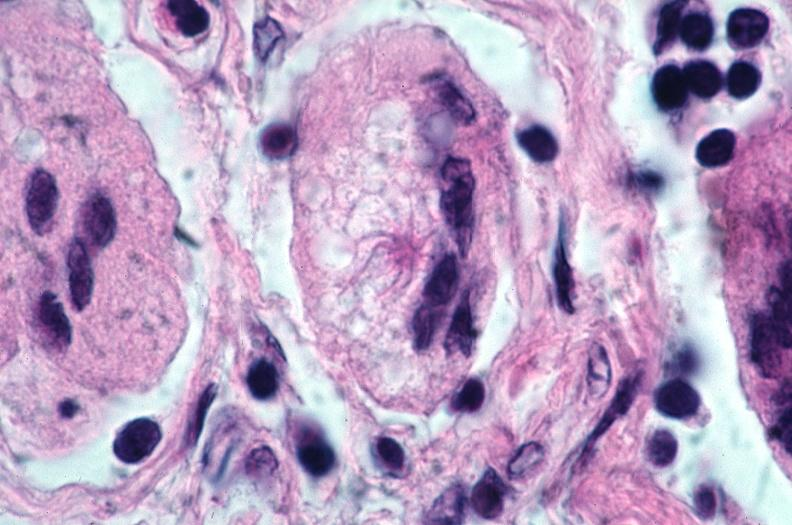what does this image show?
Answer the question using a single word or phrase. Lung 